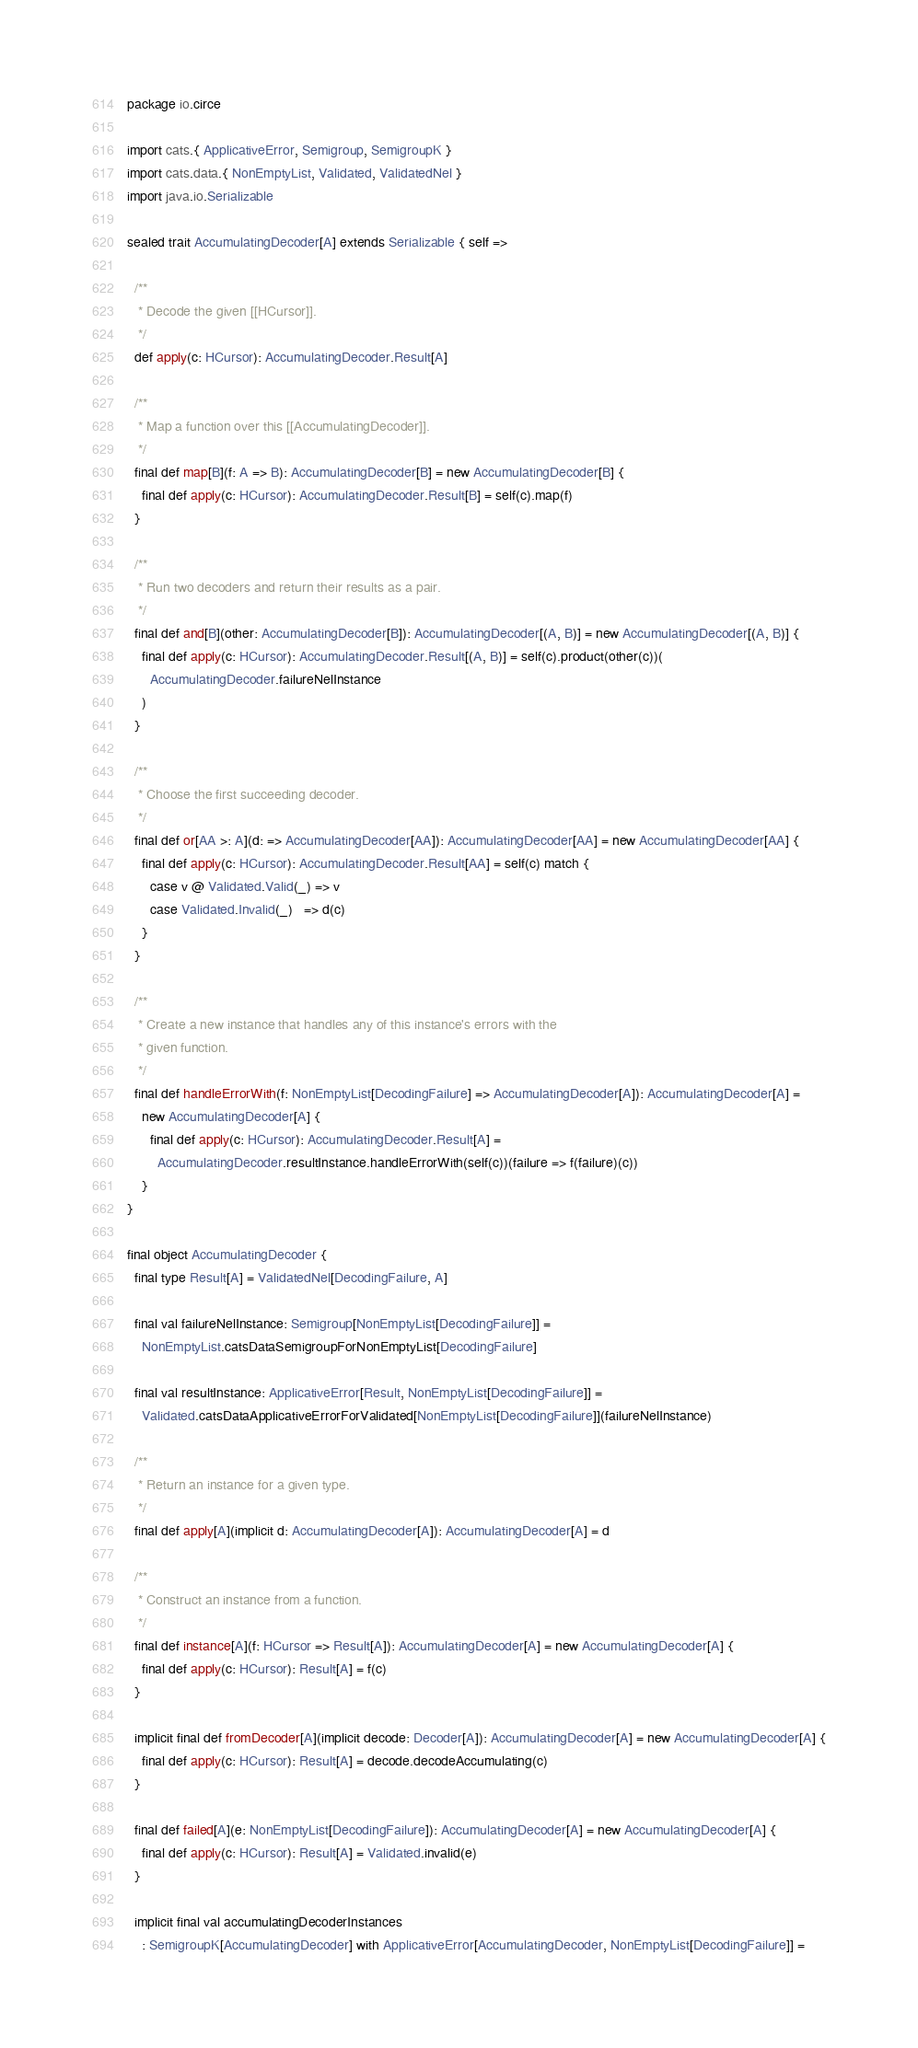<code> <loc_0><loc_0><loc_500><loc_500><_Scala_>package io.circe

import cats.{ ApplicativeError, Semigroup, SemigroupK }
import cats.data.{ NonEmptyList, Validated, ValidatedNel }
import java.io.Serializable

sealed trait AccumulatingDecoder[A] extends Serializable { self =>

  /**
   * Decode the given [[HCursor]].
   */
  def apply(c: HCursor): AccumulatingDecoder.Result[A]

  /**
   * Map a function over this [[AccumulatingDecoder]].
   */
  final def map[B](f: A => B): AccumulatingDecoder[B] = new AccumulatingDecoder[B] {
    final def apply(c: HCursor): AccumulatingDecoder.Result[B] = self(c).map(f)
  }

  /**
   * Run two decoders and return their results as a pair.
   */
  final def and[B](other: AccumulatingDecoder[B]): AccumulatingDecoder[(A, B)] = new AccumulatingDecoder[(A, B)] {
    final def apply(c: HCursor): AccumulatingDecoder.Result[(A, B)] = self(c).product(other(c))(
      AccumulatingDecoder.failureNelInstance
    )
  }

  /**
   * Choose the first succeeding decoder.
   */
  final def or[AA >: A](d: => AccumulatingDecoder[AA]): AccumulatingDecoder[AA] = new AccumulatingDecoder[AA] {
    final def apply(c: HCursor): AccumulatingDecoder.Result[AA] = self(c) match {
      case v @ Validated.Valid(_) => v
      case Validated.Invalid(_)   => d(c)
    }
  }

  /**
   * Create a new instance that handles any of this instance's errors with the
   * given function.
   */
  final def handleErrorWith(f: NonEmptyList[DecodingFailure] => AccumulatingDecoder[A]): AccumulatingDecoder[A] =
    new AccumulatingDecoder[A] {
      final def apply(c: HCursor): AccumulatingDecoder.Result[A] =
        AccumulatingDecoder.resultInstance.handleErrorWith(self(c))(failure => f(failure)(c))
    }
}

final object AccumulatingDecoder {
  final type Result[A] = ValidatedNel[DecodingFailure, A]

  final val failureNelInstance: Semigroup[NonEmptyList[DecodingFailure]] =
    NonEmptyList.catsDataSemigroupForNonEmptyList[DecodingFailure]

  final val resultInstance: ApplicativeError[Result, NonEmptyList[DecodingFailure]] =
    Validated.catsDataApplicativeErrorForValidated[NonEmptyList[DecodingFailure]](failureNelInstance)

  /**
   * Return an instance for a given type.
   */
  final def apply[A](implicit d: AccumulatingDecoder[A]): AccumulatingDecoder[A] = d

  /**
   * Construct an instance from a function.
   */
  final def instance[A](f: HCursor => Result[A]): AccumulatingDecoder[A] = new AccumulatingDecoder[A] {
    final def apply(c: HCursor): Result[A] = f(c)
  }

  implicit final def fromDecoder[A](implicit decode: Decoder[A]): AccumulatingDecoder[A] = new AccumulatingDecoder[A] {
    final def apply(c: HCursor): Result[A] = decode.decodeAccumulating(c)
  }

  final def failed[A](e: NonEmptyList[DecodingFailure]): AccumulatingDecoder[A] = new AccumulatingDecoder[A] {
    final def apply(c: HCursor): Result[A] = Validated.invalid(e)
  }

  implicit final val accumulatingDecoderInstances
    : SemigroupK[AccumulatingDecoder] with ApplicativeError[AccumulatingDecoder, NonEmptyList[DecodingFailure]] =</code> 